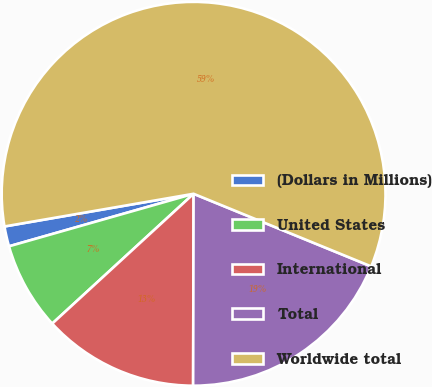Convert chart. <chart><loc_0><loc_0><loc_500><loc_500><pie_chart><fcel>(Dollars in Millions)<fcel>United States<fcel>International<fcel>Total<fcel>Worldwide total<nl><fcel>1.69%<fcel>7.41%<fcel>13.14%<fcel>18.86%<fcel>58.9%<nl></chart> 